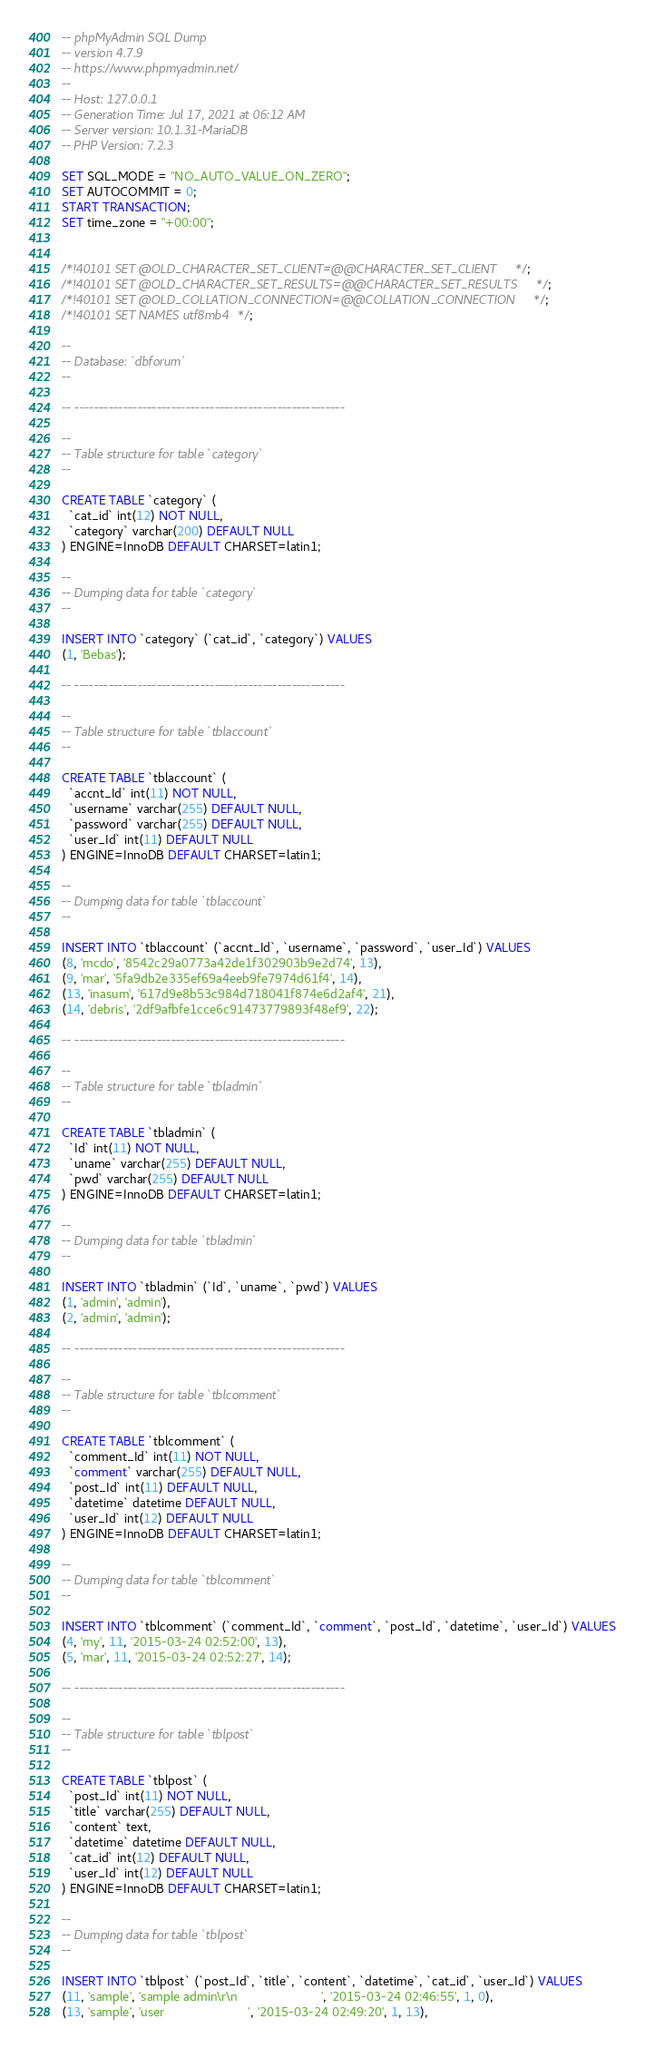<code> <loc_0><loc_0><loc_500><loc_500><_SQL_>-- phpMyAdmin SQL Dump
-- version 4.7.9
-- https://www.phpmyadmin.net/
--
-- Host: 127.0.0.1
-- Generation Time: Jul 17, 2021 at 06:12 AM
-- Server version: 10.1.31-MariaDB
-- PHP Version: 7.2.3

SET SQL_MODE = "NO_AUTO_VALUE_ON_ZERO";
SET AUTOCOMMIT = 0;
START TRANSACTION;
SET time_zone = "+00:00";


/*!40101 SET @OLD_CHARACTER_SET_CLIENT=@@CHARACTER_SET_CLIENT */;
/*!40101 SET @OLD_CHARACTER_SET_RESULTS=@@CHARACTER_SET_RESULTS */;
/*!40101 SET @OLD_COLLATION_CONNECTION=@@COLLATION_CONNECTION */;
/*!40101 SET NAMES utf8mb4 */;

--
-- Database: `dbforum`
--

-- --------------------------------------------------------

--
-- Table structure for table `category`
--

CREATE TABLE `category` (
  `cat_id` int(12) NOT NULL,
  `category` varchar(200) DEFAULT NULL
) ENGINE=InnoDB DEFAULT CHARSET=latin1;

--
-- Dumping data for table `category`
--

INSERT INTO `category` (`cat_id`, `category`) VALUES
(1, 'Bebas');

-- --------------------------------------------------------

--
-- Table structure for table `tblaccount`
--

CREATE TABLE `tblaccount` (
  `accnt_Id` int(11) NOT NULL,
  `username` varchar(255) DEFAULT NULL,
  `password` varchar(255) DEFAULT NULL,
  `user_Id` int(11) DEFAULT NULL
) ENGINE=InnoDB DEFAULT CHARSET=latin1;

--
-- Dumping data for table `tblaccount`
--

INSERT INTO `tblaccount` (`accnt_Id`, `username`, `password`, `user_Id`) VALUES
(8, 'mcdo', '8542c29a0773a42de1f302903b9e2d74', 13),
(9, 'mar', '5fa9db2e335ef69a4eeb9fe7974d61f4', 14),
(13, 'inasum', '617d9e8b53c984d718041f874e6d2af4', 21),
(14, 'debris', '2df9afbfe1cce6c91473779893f48ef9', 22);

-- --------------------------------------------------------

--
-- Table structure for table `tbladmin`
--

CREATE TABLE `tbladmin` (
  `Id` int(11) NOT NULL,
  `uname` varchar(255) DEFAULT NULL,
  `pwd` varchar(255) DEFAULT NULL
) ENGINE=InnoDB DEFAULT CHARSET=latin1;

--
-- Dumping data for table `tbladmin`
--

INSERT INTO `tbladmin` (`Id`, `uname`, `pwd`) VALUES
(1, 'admin', 'admin'),
(2, 'admin', 'admin');

-- --------------------------------------------------------

--
-- Table structure for table `tblcomment`
--

CREATE TABLE `tblcomment` (
  `comment_Id` int(11) NOT NULL,
  `comment` varchar(255) DEFAULT NULL,
  `post_Id` int(11) DEFAULT NULL,
  `datetime` datetime DEFAULT NULL,
  `user_Id` int(12) DEFAULT NULL
) ENGINE=InnoDB DEFAULT CHARSET=latin1;

--
-- Dumping data for table `tblcomment`
--

INSERT INTO `tblcomment` (`comment_Id`, `comment`, `post_Id`, `datetime`, `user_Id`) VALUES
(4, 'my', 11, '2015-03-24 02:52:00', 13),
(5, 'mar', 11, '2015-03-24 02:52:27', 14);

-- --------------------------------------------------------

--
-- Table structure for table `tblpost`
--

CREATE TABLE `tblpost` (
  `post_Id` int(11) NOT NULL,
  `title` varchar(255) DEFAULT NULL,
  `content` text,
  `datetime` datetime DEFAULT NULL,
  `cat_id` int(12) DEFAULT NULL,
  `user_Id` int(12) DEFAULT NULL
) ENGINE=InnoDB DEFAULT CHARSET=latin1;

--
-- Dumping data for table `tblpost`
--

INSERT INTO `tblpost` (`post_Id`, `title`, `content`, `datetime`, `cat_id`, `user_Id`) VALUES
(11, 'sample', 'sample admin\r\n                        ', '2015-03-24 02:46:55', 1, 0),
(13, 'sample', 'user                        ', '2015-03-24 02:49:20', 1, 13),</code> 